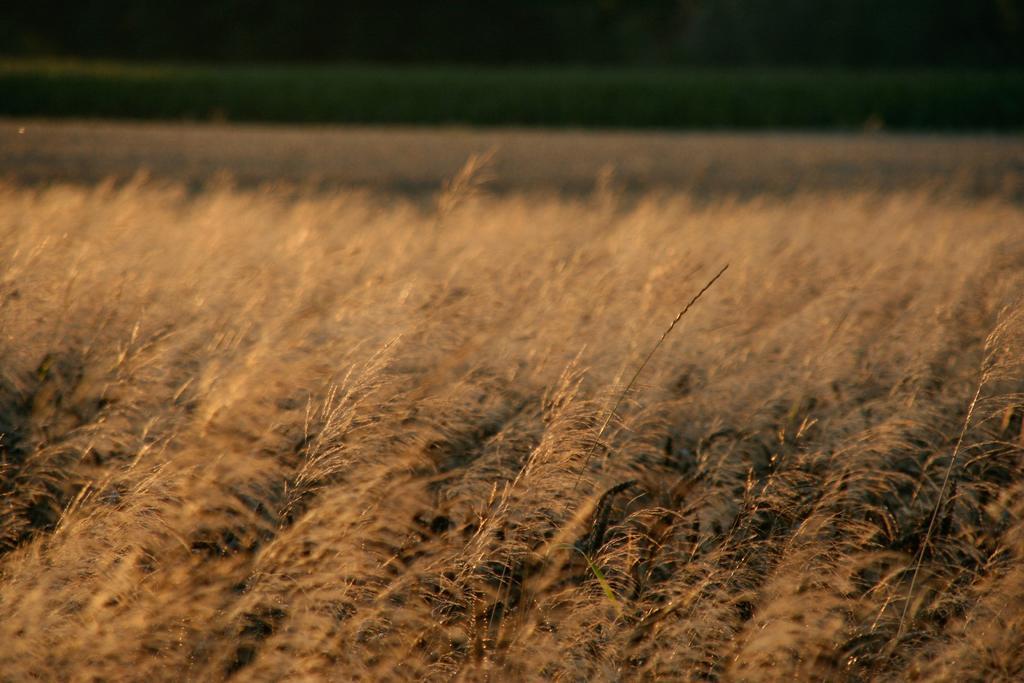Describe this image in one or two sentences. In this image we can see grass and a blurry background. 